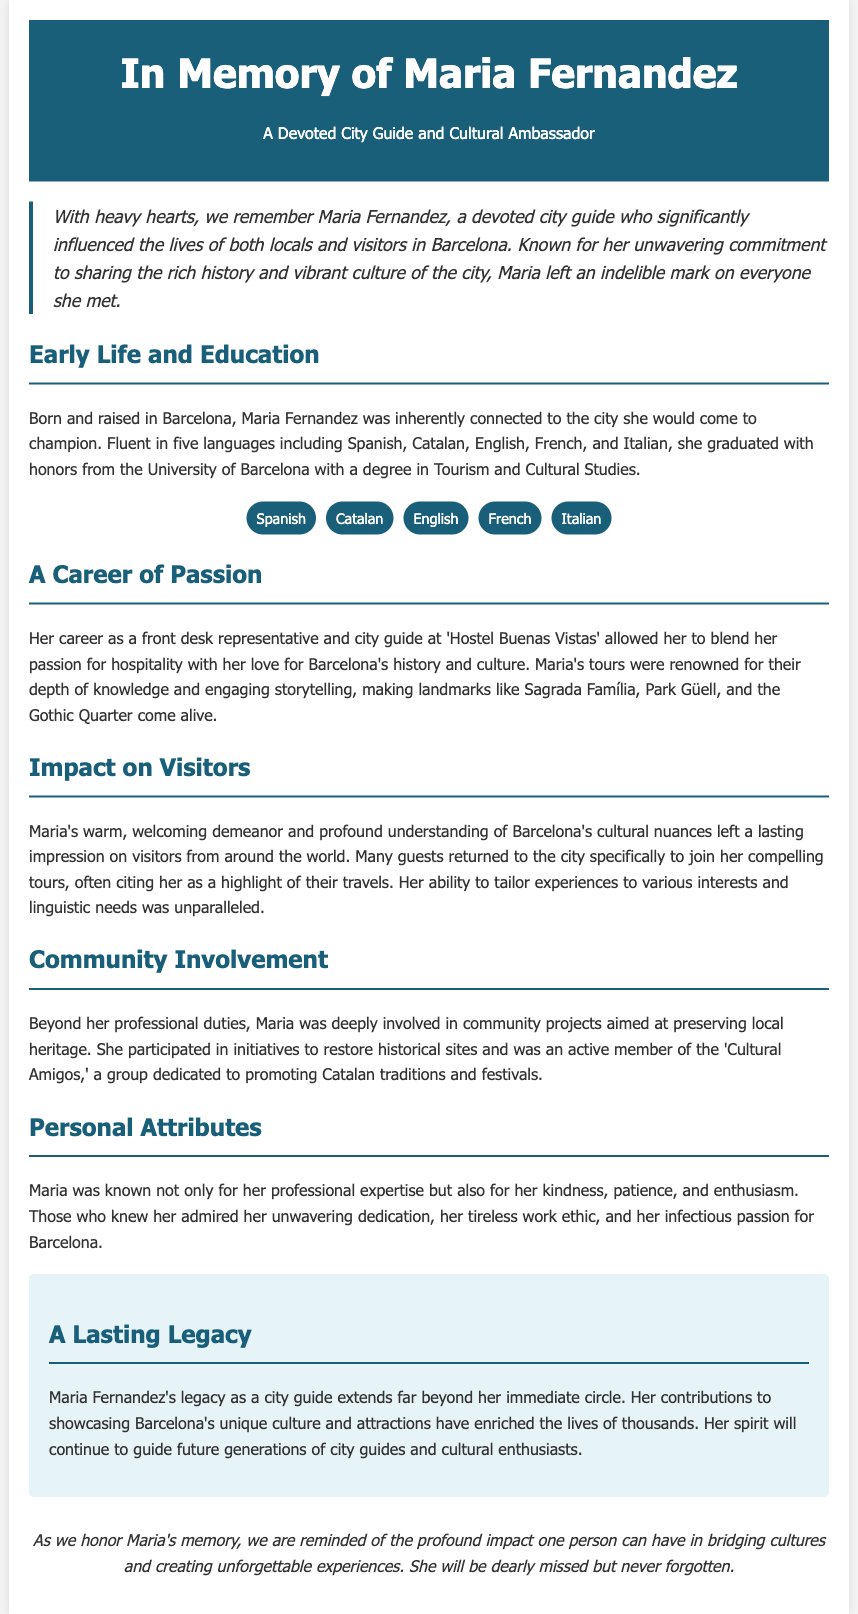What was the full name of the city guide? The full name of the city guide mentioned in the document is Maria Fernandez.
Answer: Maria Fernandez In which city did Maria work as a city guide? The document states that Maria worked as a city guide in Barcelona.
Answer: Barcelona How many languages was Maria fluent in? The document indicates that Maria was fluent in five languages.
Answer: five What was Maria's degree in? According to the document, Maria graduated with a degree in Tourism and Cultural Studies.
Answer: Tourism and Cultural Studies What was the name of the hostel where Maria worked? The document specifies that she worked at 'Hostel Buenas Vistas'.
Answer: Hostel Buenas Vistas What was one of the community projects Maria was involved in? The document mentions Maria participated in initiatives to restore historical sites.
Answer: restore historical sites How did Maria's tours impact visitors? The document describes that many guests cited her as a highlight of their travels.
Answer: highlight of their travels What was a personal attribute of Maria highlighted in the document? The document notes her kindness as one of her personal attributes.
Answer: kindness What type of legacy did Maria leave as described in the document? The document states that Maria's legacy as a city guide extends far beyond her immediate circle.
Answer: extends far beyond her immediate circle 